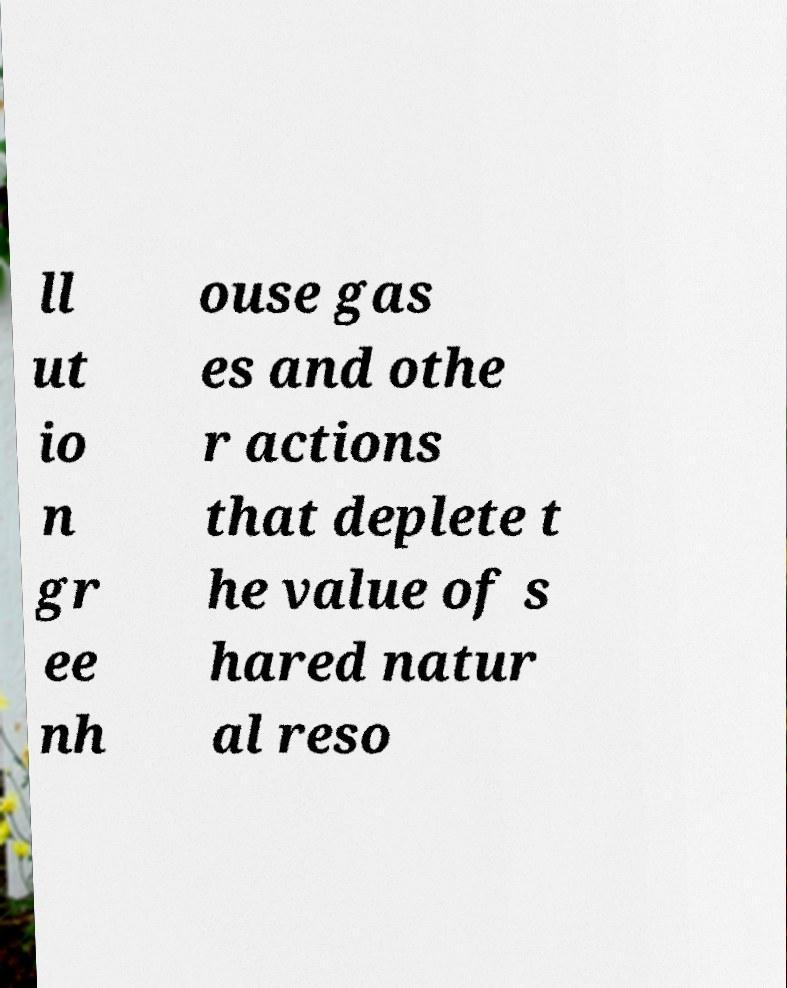Can you read and provide the text displayed in the image?This photo seems to have some interesting text. Can you extract and type it out for me? ll ut io n gr ee nh ouse gas es and othe r actions that deplete t he value of s hared natur al reso 